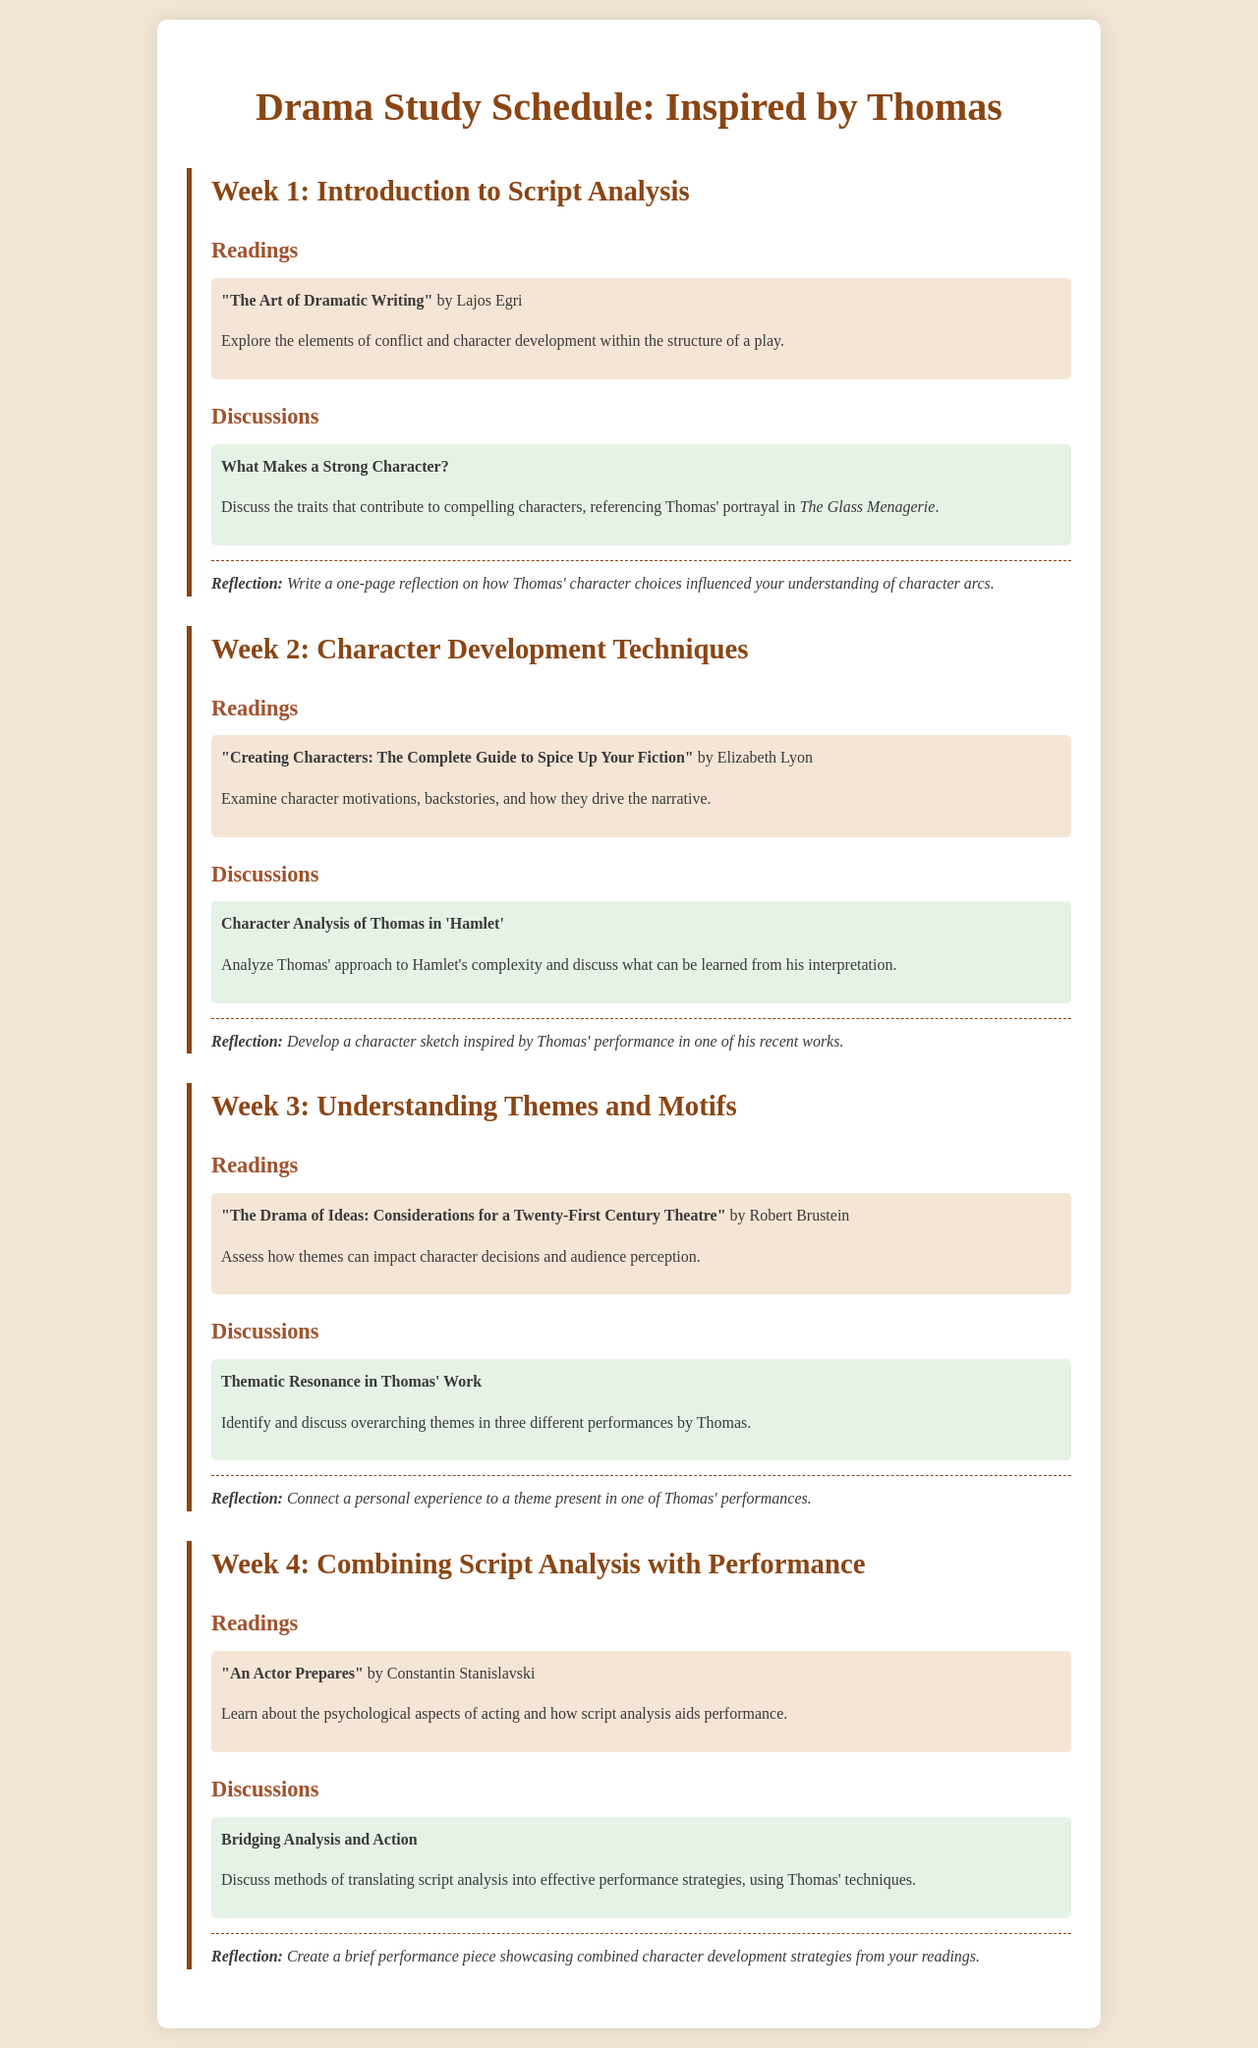What is the title of the schedule? The title is presented at the top of the document, summarizing its content related to drama studies inspired by Thomas.
Answer: Drama Study Schedule: Inspired by Thomas Who is the author of "The Art of Dramatic Writing"? This information is found in the Week 1 readings section, naming the author associated with that work.
Answer: Lajos Egri What is the focus of the discussion in Week 2? The discussion in Week 2 centers around Thomas' performance and insights on a specific character role.
Answer: Character Analysis of Thomas in 'Hamlet' How many weeks are included in the schedule? The document outlines a study plan that spans over several weeks.
Answer: 4 What type of reflection is requested in Week 3? The reflection for Week 3 asks to connect a personal experience to a theme from one of Thomas' performances.
Answer: Connect a personal experience to a theme present in one of Thomas' performances What is the reading assigned for Week 4? The reading listed in Week 4 focuses on acting and script analysis.
Answer: "An Actor Prepares" What is a key theme discussed in Thomas' performances as noted in the document? The focus group activity pertains to identifying themes across various performances, emphasizing thematic elements.
Answer: Thematic Resonance in Thomas' Work What kind of performance piece should be created in Week 4? The document specifies that the performance piece should illustrate combined strategies from readings.
Answer: Brief performance piece showcasing combined character development strategies 